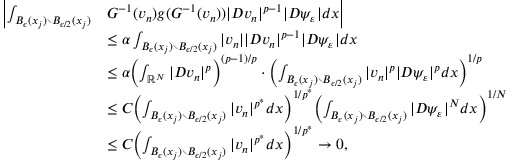Convert formula to latex. <formula><loc_0><loc_0><loc_500><loc_500>\begin{array} { r l } { \left | \int _ { B _ { \epsilon } ( x _ { j } ) \ B _ { \epsilon / 2 } ( x _ { j } ) } } & { G ^ { - 1 } ( v _ { n } ) g ( G ^ { - 1 } ( v _ { n } ) ) | D v _ { n } | ^ { p - 1 } | D \psi _ { \varepsilon } | d x \right | } \\ & { \leq \alpha \int _ { B _ { \epsilon } ( x _ { j } ) \ B _ { \epsilon / 2 } ( x _ { j } ) } | v _ { n } | | D v _ { n } | ^ { p - 1 } | D \psi _ { \varepsilon } | d x } \\ & { \leq \alpha \left ( \int _ { \mathbb { R } ^ { N } } | D v _ { n } | ^ { p } \right ) ^ { ( p - 1 ) / p } \cdot \left ( \int _ { B _ { \epsilon } ( x _ { j } ) \ B _ { \epsilon / 2 } ( x _ { j } ) } | v _ { n } | ^ { p } | D \psi _ { \varepsilon } | ^ { p } d x \right ) ^ { 1 / p } } \\ & { \leq C \left ( \int _ { B _ { \epsilon } ( x _ { j } ) \ B _ { \epsilon / 2 } ( x _ { j } ) } | v _ { n } | ^ { p ^ { * } } d x \right ) ^ { 1 / p ^ { * } } \left ( \int _ { B _ { \epsilon } ( x _ { j } ) \ B _ { \epsilon / 2 } ( x _ { j } ) } | D \psi _ { \varepsilon } | ^ { N } d x \right ) ^ { 1 / N } } \\ & { \leq C \left ( \int _ { B _ { \epsilon } ( x _ { j } ) \ B _ { \epsilon / 2 } ( x _ { j } ) } | v _ { n } | ^ { p ^ { * } } d x \right ) ^ { 1 / p ^ { * } } \to 0 , } \end{array}</formula> 